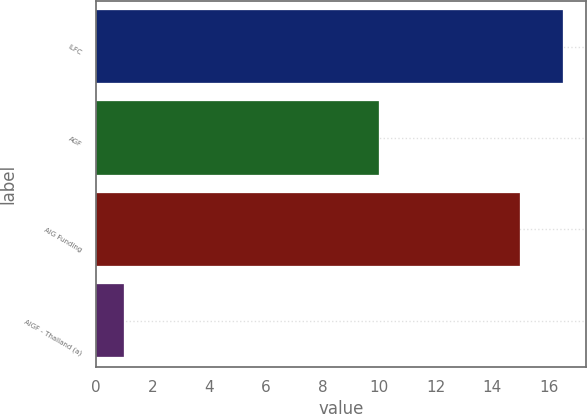Convert chart to OTSL. <chart><loc_0><loc_0><loc_500><loc_500><bar_chart><fcel>ILFC<fcel>AGF<fcel>AIG Funding<fcel>AIGF - Thailand (a)<nl><fcel>16.5<fcel>10<fcel>15<fcel>1<nl></chart> 